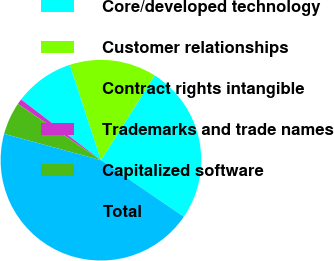Convert chart. <chart><loc_0><loc_0><loc_500><loc_500><pie_chart><fcel>Core/developed technology<fcel>Customer relationships<fcel>Contract rights intangible<fcel>Trademarks and trade names<fcel>Capitalized software<fcel>Total<nl><fcel>25.55%<fcel>14.01%<fcel>9.63%<fcel>0.87%<fcel>5.25%<fcel>44.69%<nl></chart> 